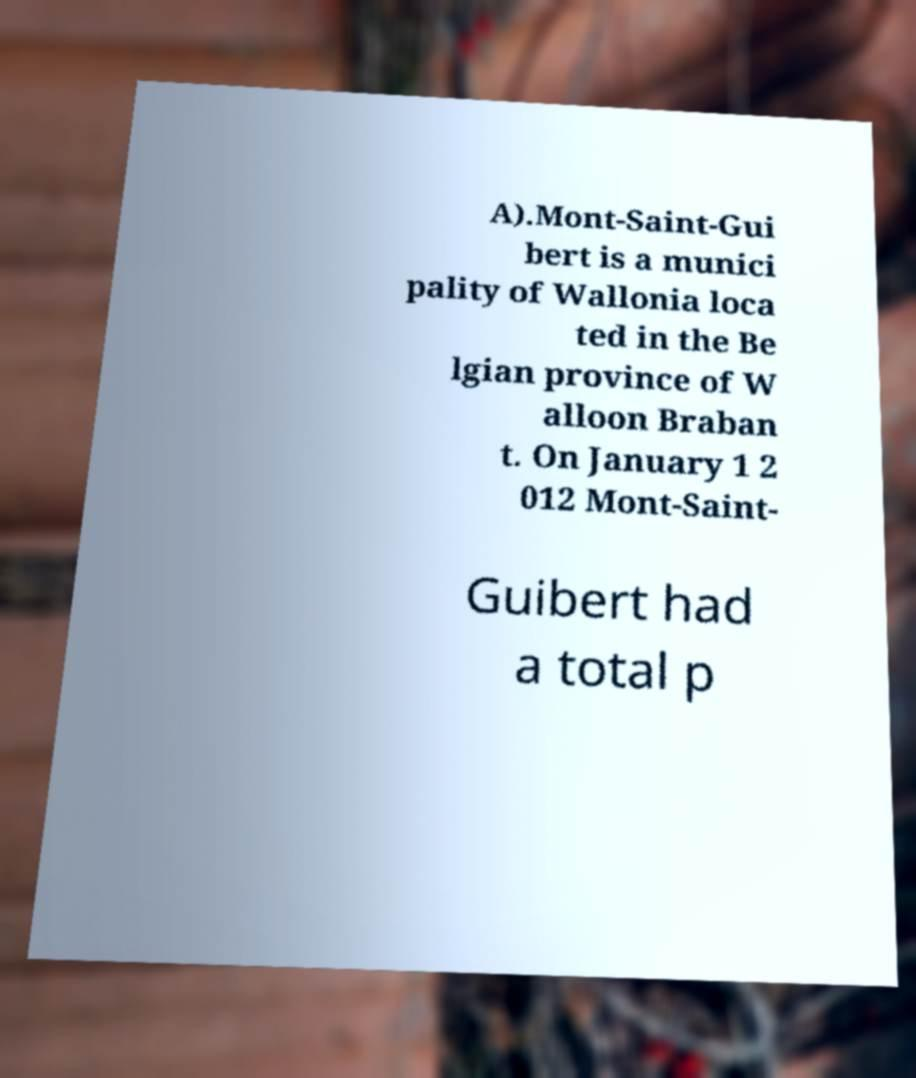Can you read and provide the text displayed in the image?This photo seems to have some interesting text. Can you extract and type it out for me? A).Mont-Saint-Gui bert is a munici pality of Wallonia loca ted in the Be lgian province of W alloon Braban t. On January 1 2 012 Mont-Saint- Guibert had a total p 